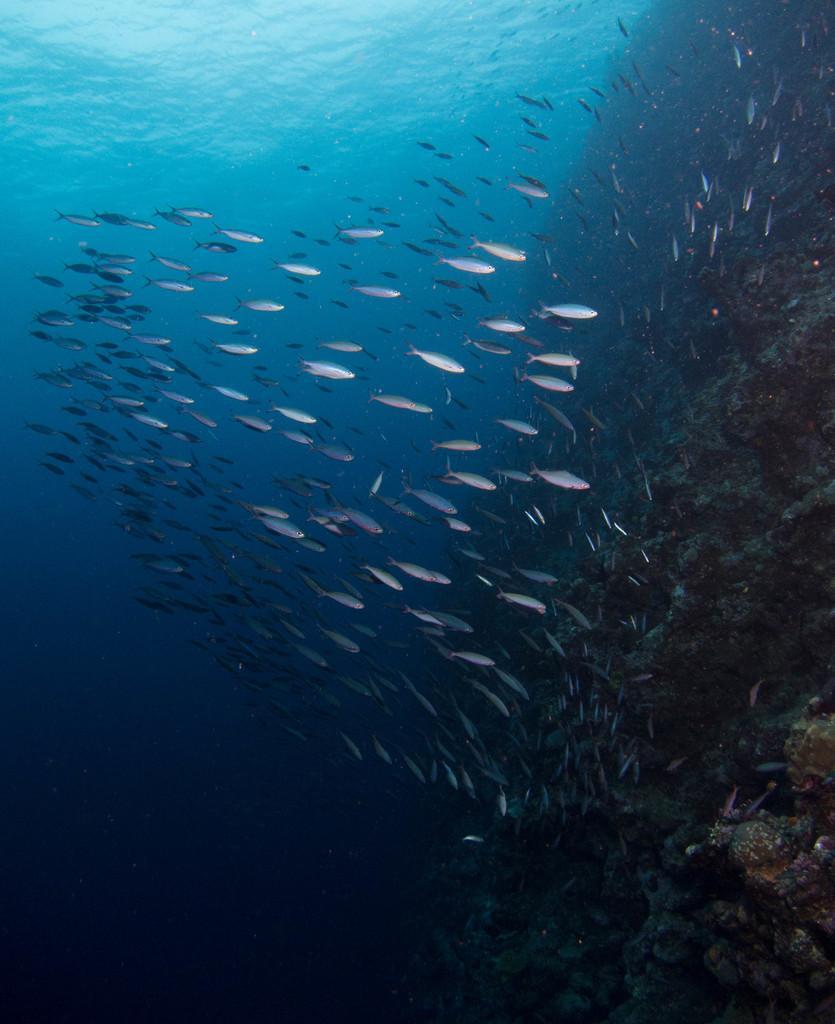Please provide a concise description of this image. In this image, we can see fishes in the water. Here it seems like a rocks on the right side of the image. 